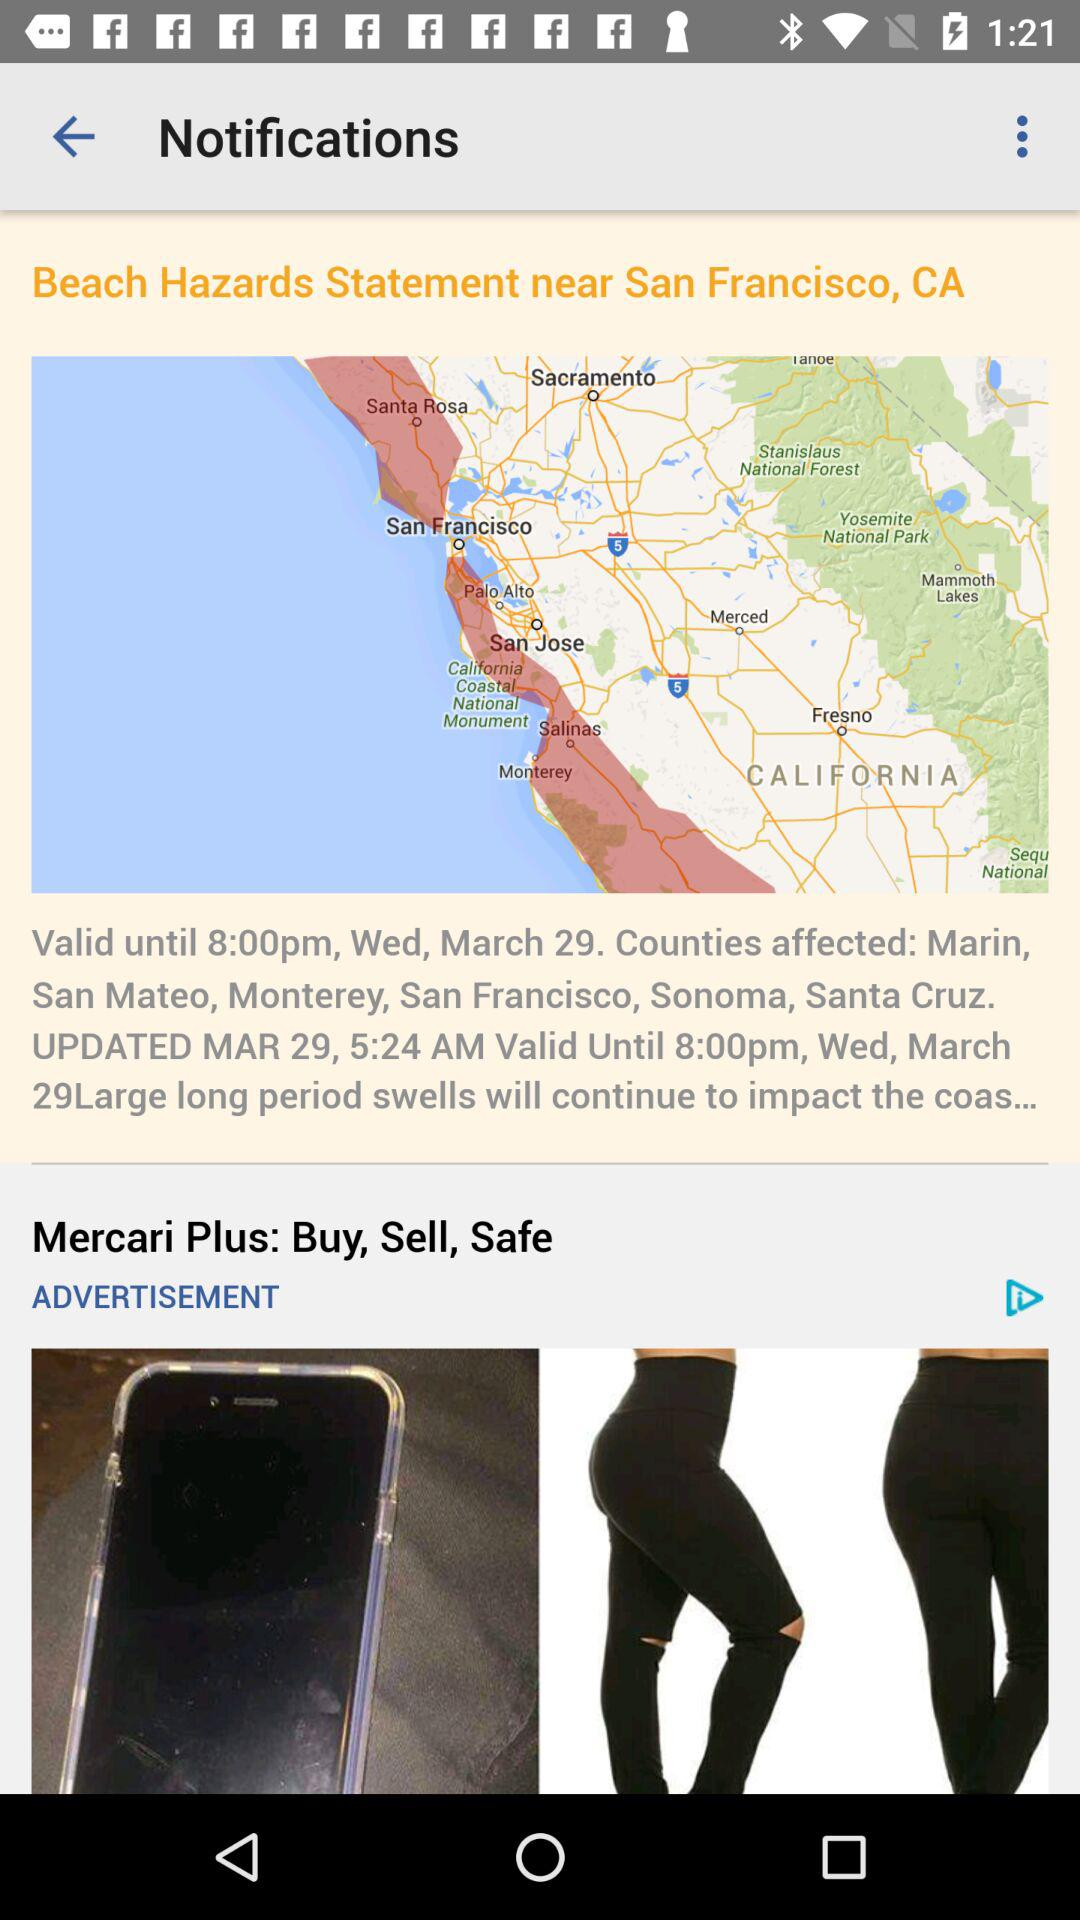What is the updated date of the notification? The updated date is March 29. 